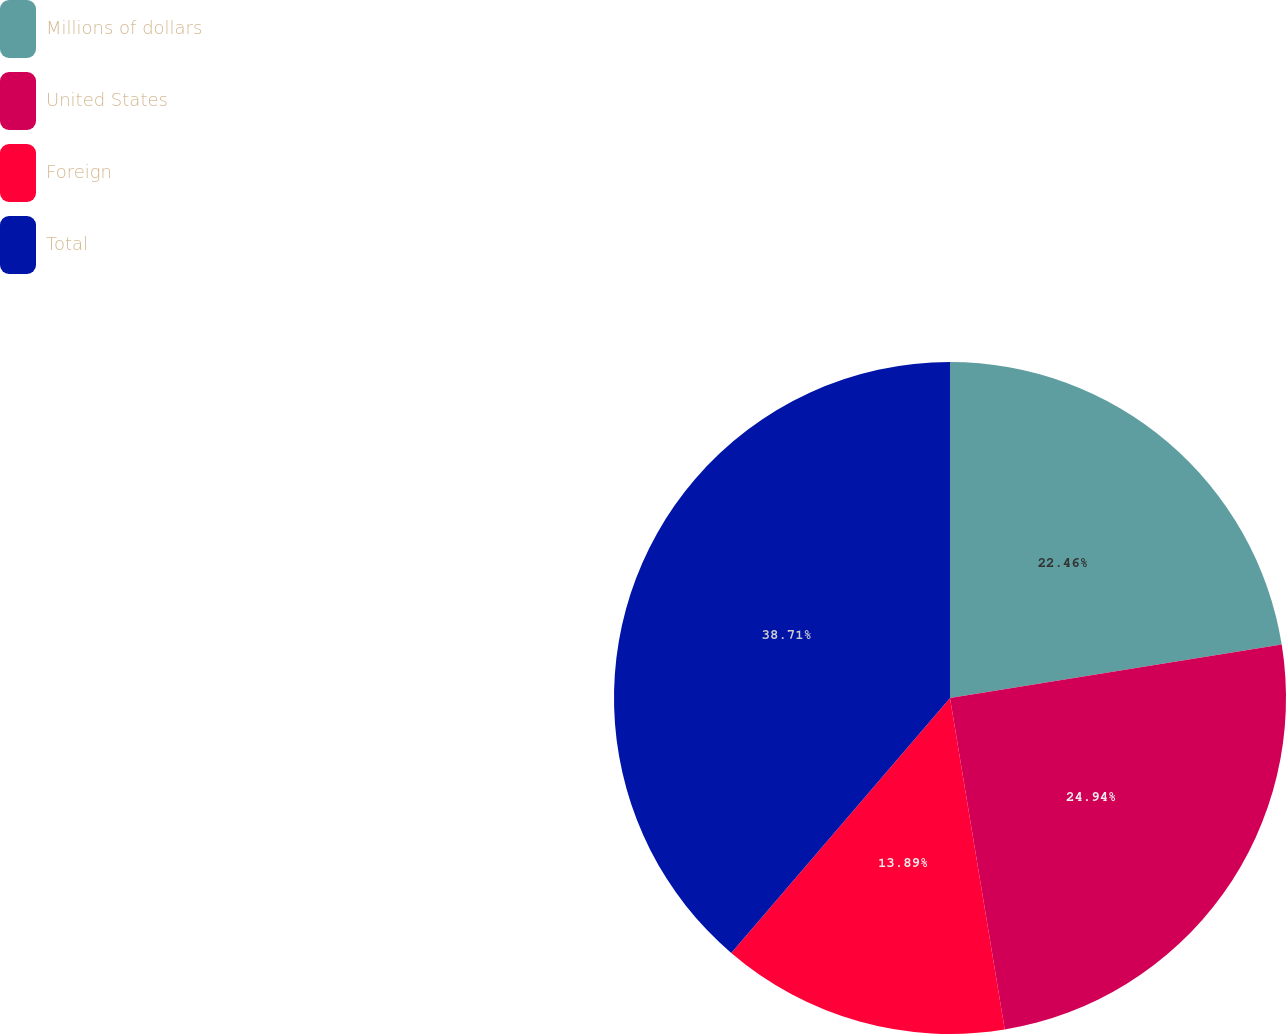Convert chart. <chart><loc_0><loc_0><loc_500><loc_500><pie_chart><fcel>Millions of dollars<fcel>United States<fcel>Foreign<fcel>Total<nl><fcel>22.46%<fcel>24.94%<fcel>13.89%<fcel>38.72%<nl></chart> 